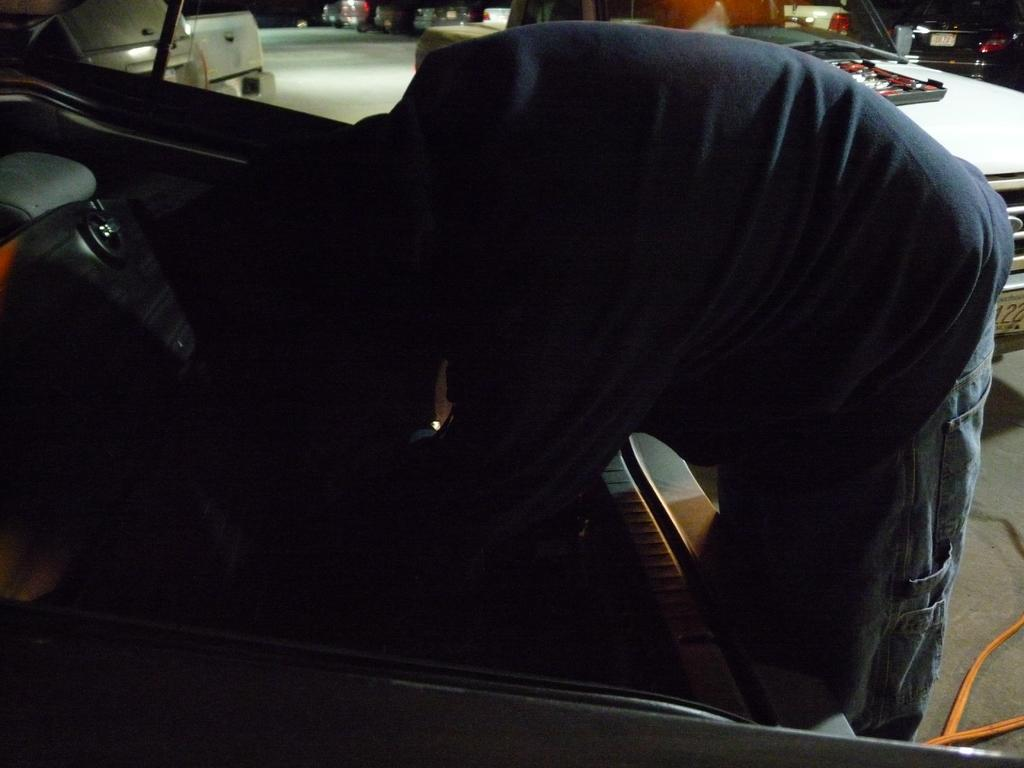Who or what is in the image? There is a person in the image. What is the person doing or where are they located in the image? The person is in front of a vehicle. Can you describe the surroundings or other objects in the image? There are multiple vehicles visible in the image. What type of goose can be seen moving around in the image? There is no goose present in the image, and therefore no such movement can be observed. 